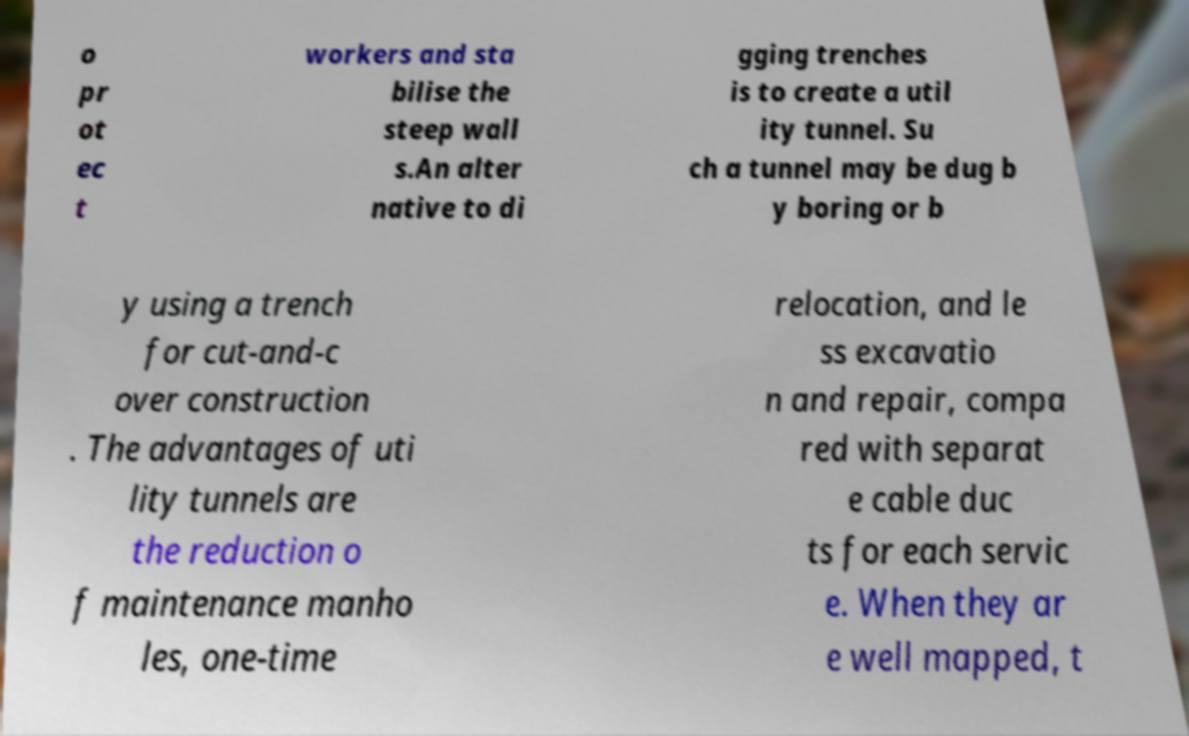What messages or text are displayed in this image? I need them in a readable, typed format. o pr ot ec t workers and sta bilise the steep wall s.An alter native to di gging trenches is to create a util ity tunnel. Su ch a tunnel may be dug b y boring or b y using a trench for cut-and-c over construction . The advantages of uti lity tunnels are the reduction o f maintenance manho les, one-time relocation, and le ss excavatio n and repair, compa red with separat e cable duc ts for each servic e. When they ar e well mapped, t 